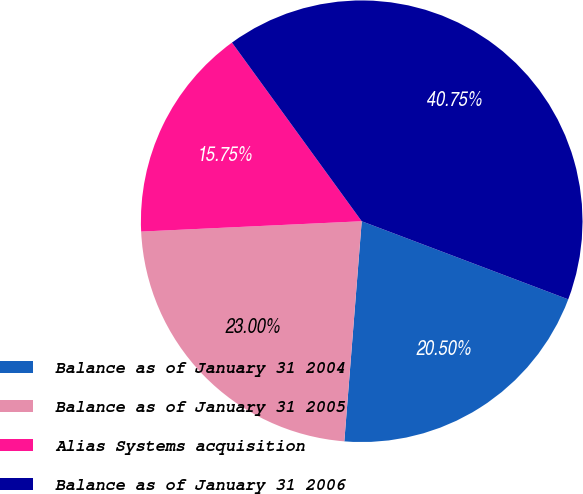<chart> <loc_0><loc_0><loc_500><loc_500><pie_chart><fcel>Balance as of January 31 2004<fcel>Balance as of January 31 2005<fcel>Alias Systems acquisition<fcel>Balance as of January 31 2006<nl><fcel>20.5%<fcel>23.0%<fcel>15.75%<fcel>40.75%<nl></chart> 